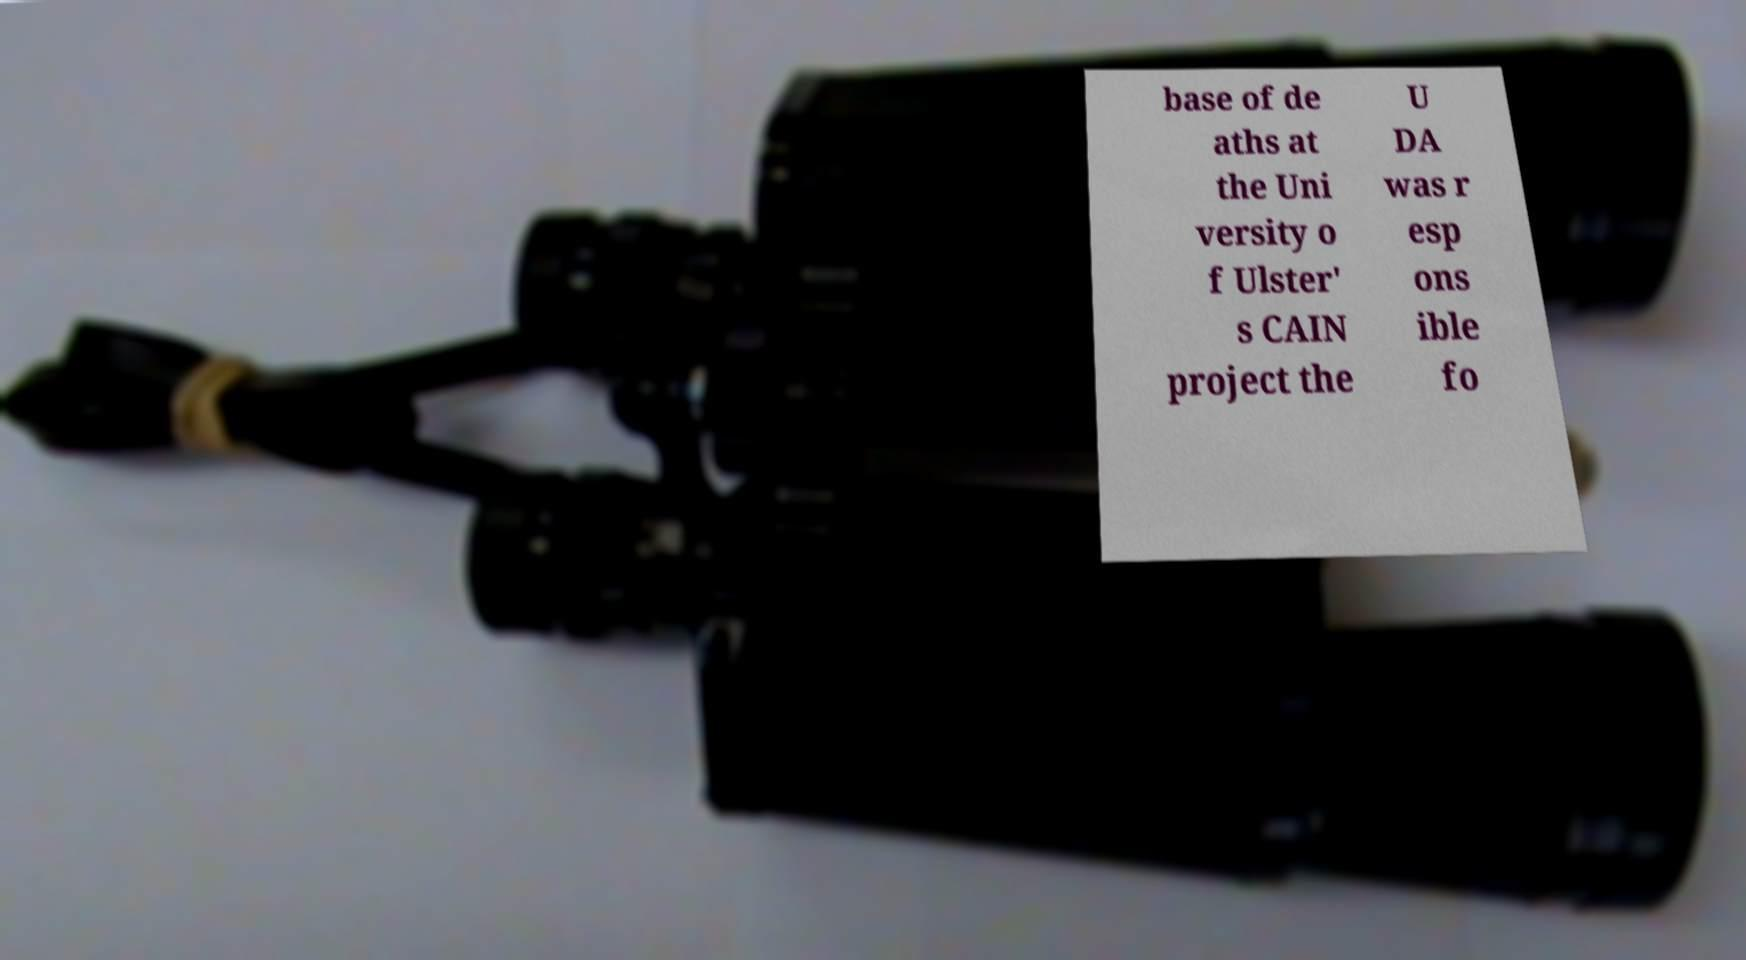For documentation purposes, I need the text within this image transcribed. Could you provide that? base of de aths at the Uni versity o f Ulster' s CAIN project the U DA was r esp ons ible fo 